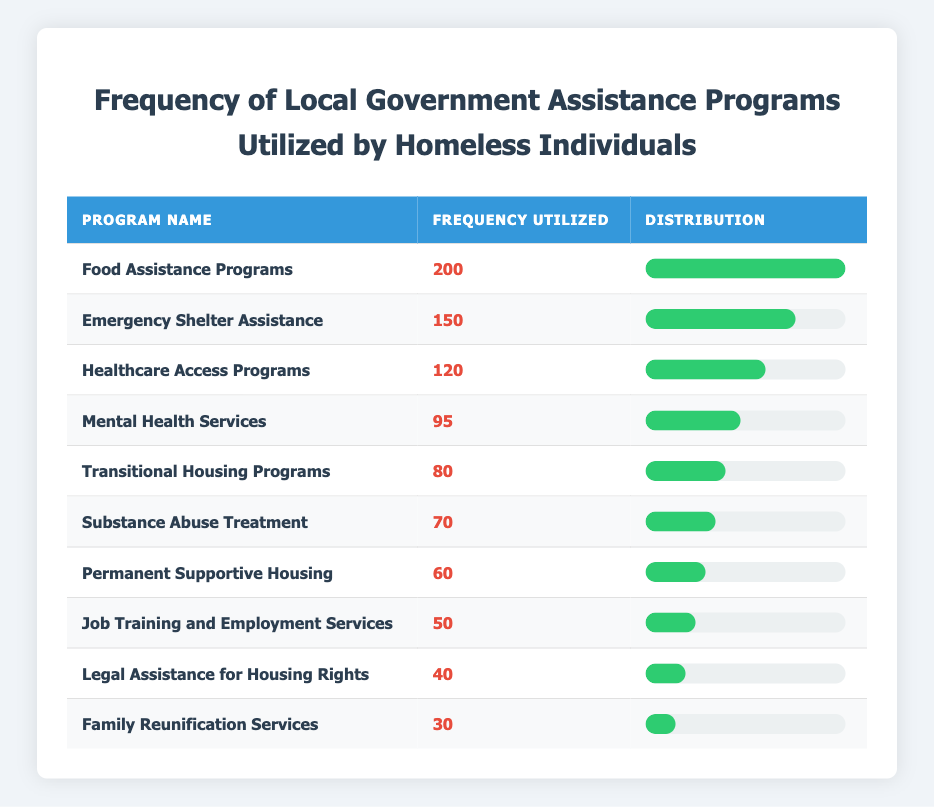What is the frequency utilized for Food Assistance Programs? The table shows that the frequency utilized for Food Assistance Programs is 200.
Answer: 200 Which assistance program has the least frequency utilized? From the table, Family Reunification Services has the least frequency utilized with a count of 30.
Answer: Family Reunification Services What is the total frequency utilized for Emergency Shelter Assistance and Transitional Housing Programs? The frequency utilized for Emergency Shelter Assistance is 150, and for Transitional Housing Programs, it is 80. Adding these gives 150 + 80 = 230.
Answer: 230 Is the frequency utilized for Mental Health Services greater than 90? The table indicates that the frequency utilized for Mental Health Services is 95, which is greater than 90. Therefore, the answer is yes.
Answer: Yes What is the average frequency utilized across all programs? To find the average, we first sum up all the frequencies: 200 + 150 + 120 + 95 + 80 + 70 + 60 + 50 + 40 + 30 = 995. There are 10 programs. Thus, the average is 995 / 10 = 99.5.
Answer: 99.5 How many programs have a frequency utilized of 80 or more? Checking the table, the programs with a frequency of 80 or more are: Food Assistance Programs (200), Emergency Shelter Assistance (150), Healthcare Access Programs (120), Mental Health Services (95), Transitional Housing Programs (80). This gives a total of 5 programs.
Answer: 5 What is the difference between the highest and lowest frequency utilized? The highest frequency utilized is 200 (Food Assistance Programs) and the lowest is 30 (Family Reunification Services). The difference is 200 - 30 = 170.
Answer: 170 Are there more programs with frequencies utilized under 50 than those over 100? The only program under 50 is Job Training and Employment Services (50), which means there’s only 1 program under 50. Programs over 100 are Food Assistance Programs (200) and Emergency Shelter Assistance (150), so there are 2 programs over 100. The answer is no.
Answer: No 